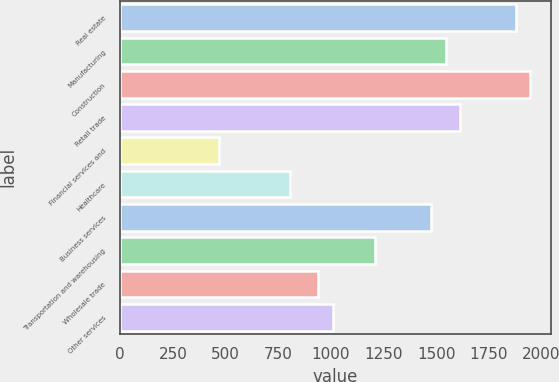Convert chart. <chart><loc_0><loc_0><loc_500><loc_500><bar_chart><fcel>Real estate<fcel>Manufacturing<fcel>Construction<fcel>Retail trade<fcel>Financial services and<fcel>Healthcare<fcel>Business services<fcel>Transportation and warehousing<fcel>Wholesale trade<fcel>Other services<nl><fcel>1879.8<fcel>1544.3<fcel>1946.9<fcel>1611.4<fcel>470.7<fcel>806.2<fcel>1477.2<fcel>1208.8<fcel>940.4<fcel>1007.5<nl></chart> 